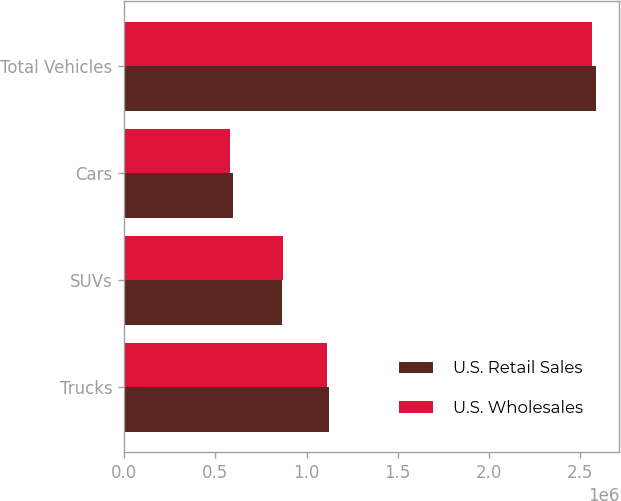Convert chart. <chart><loc_0><loc_0><loc_500><loc_500><stacked_bar_chart><ecel><fcel>Trucks<fcel>SUVs<fcel>Cars<fcel>Total Vehicles<nl><fcel>U.S. Retail Sales<fcel>1.12342e+06<fcel>867909<fcel>595390<fcel>2.58672e+06<nl><fcel>U.S. Wholesales<fcel>1.1143e+06<fcel>869725<fcel>581754<fcel>2.56578e+06<nl></chart> 